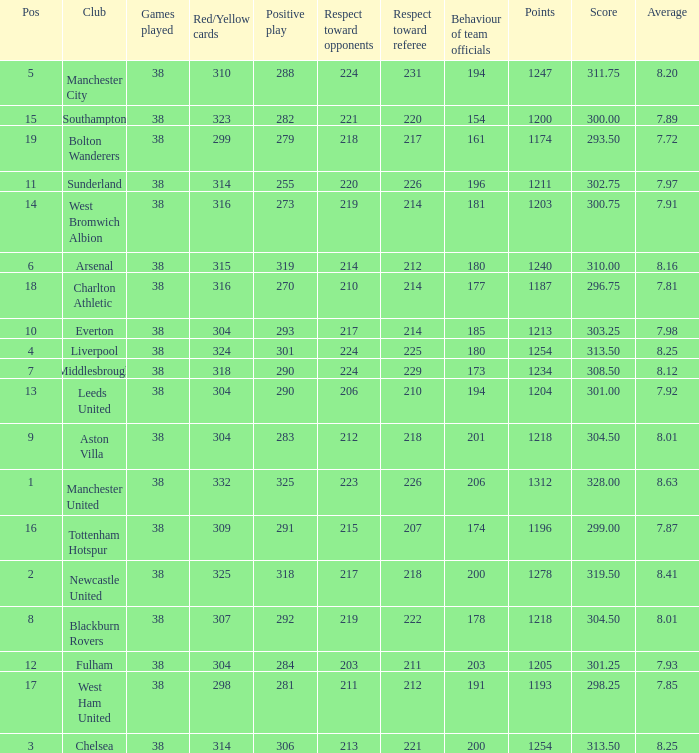Name the most red/yellow cards for positive play being 255 314.0. 